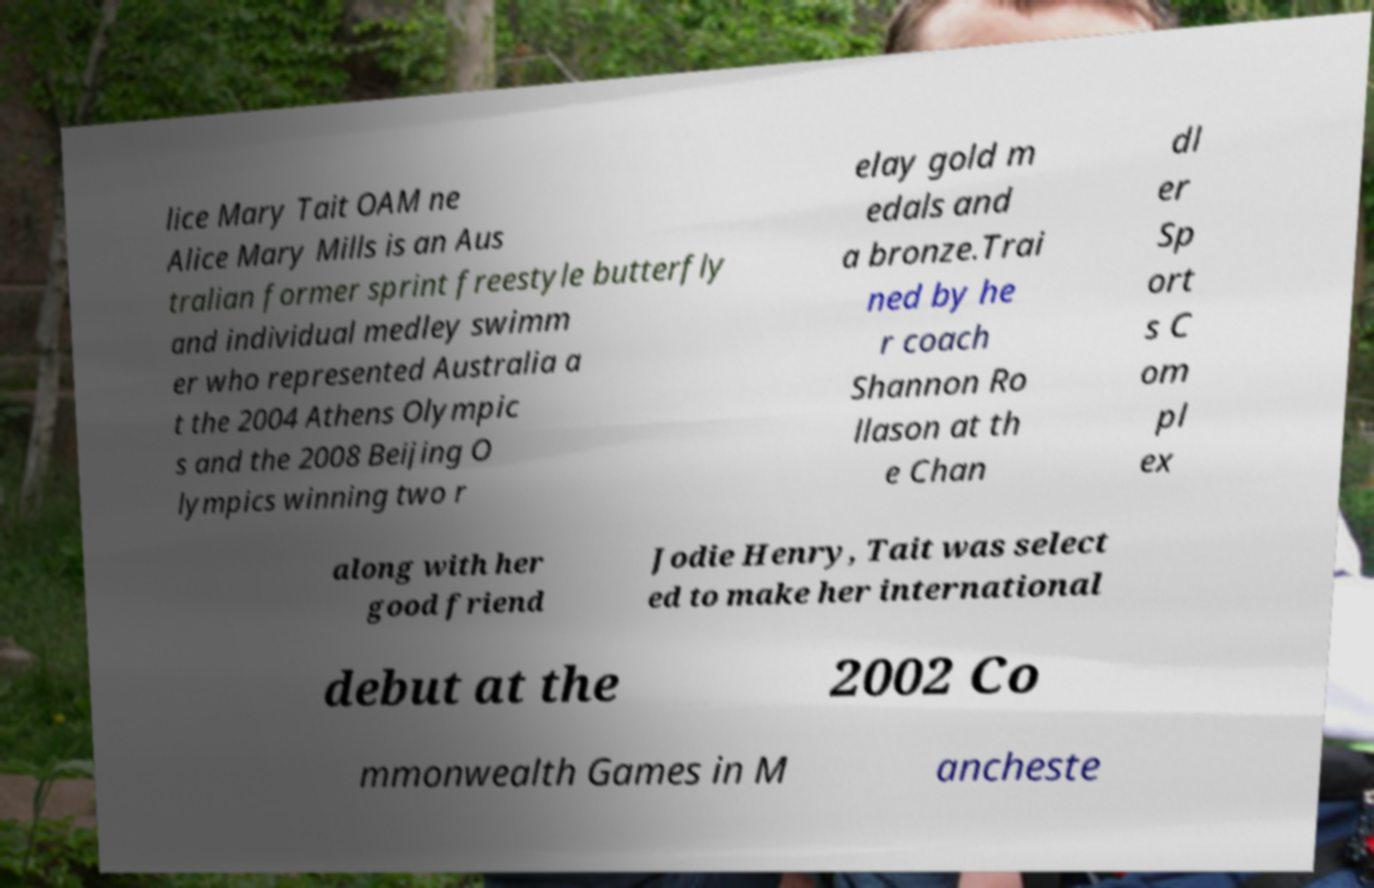Please identify and transcribe the text found in this image. lice Mary Tait OAM ne Alice Mary Mills is an Aus tralian former sprint freestyle butterfly and individual medley swimm er who represented Australia a t the 2004 Athens Olympic s and the 2008 Beijing O lympics winning two r elay gold m edals and a bronze.Trai ned by he r coach Shannon Ro llason at th e Chan dl er Sp ort s C om pl ex along with her good friend Jodie Henry, Tait was select ed to make her international debut at the 2002 Co mmonwealth Games in M ancheste 